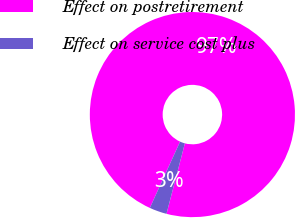Convert chart to OTSL. <chart><loc_0><loc_0><loc_500><loc_500><pie_chart><fcel>Effect on postretirement<fcel>Effect on service cost plus<nl><fcel>97.26%<fcel>2.74%<nl></chart> 